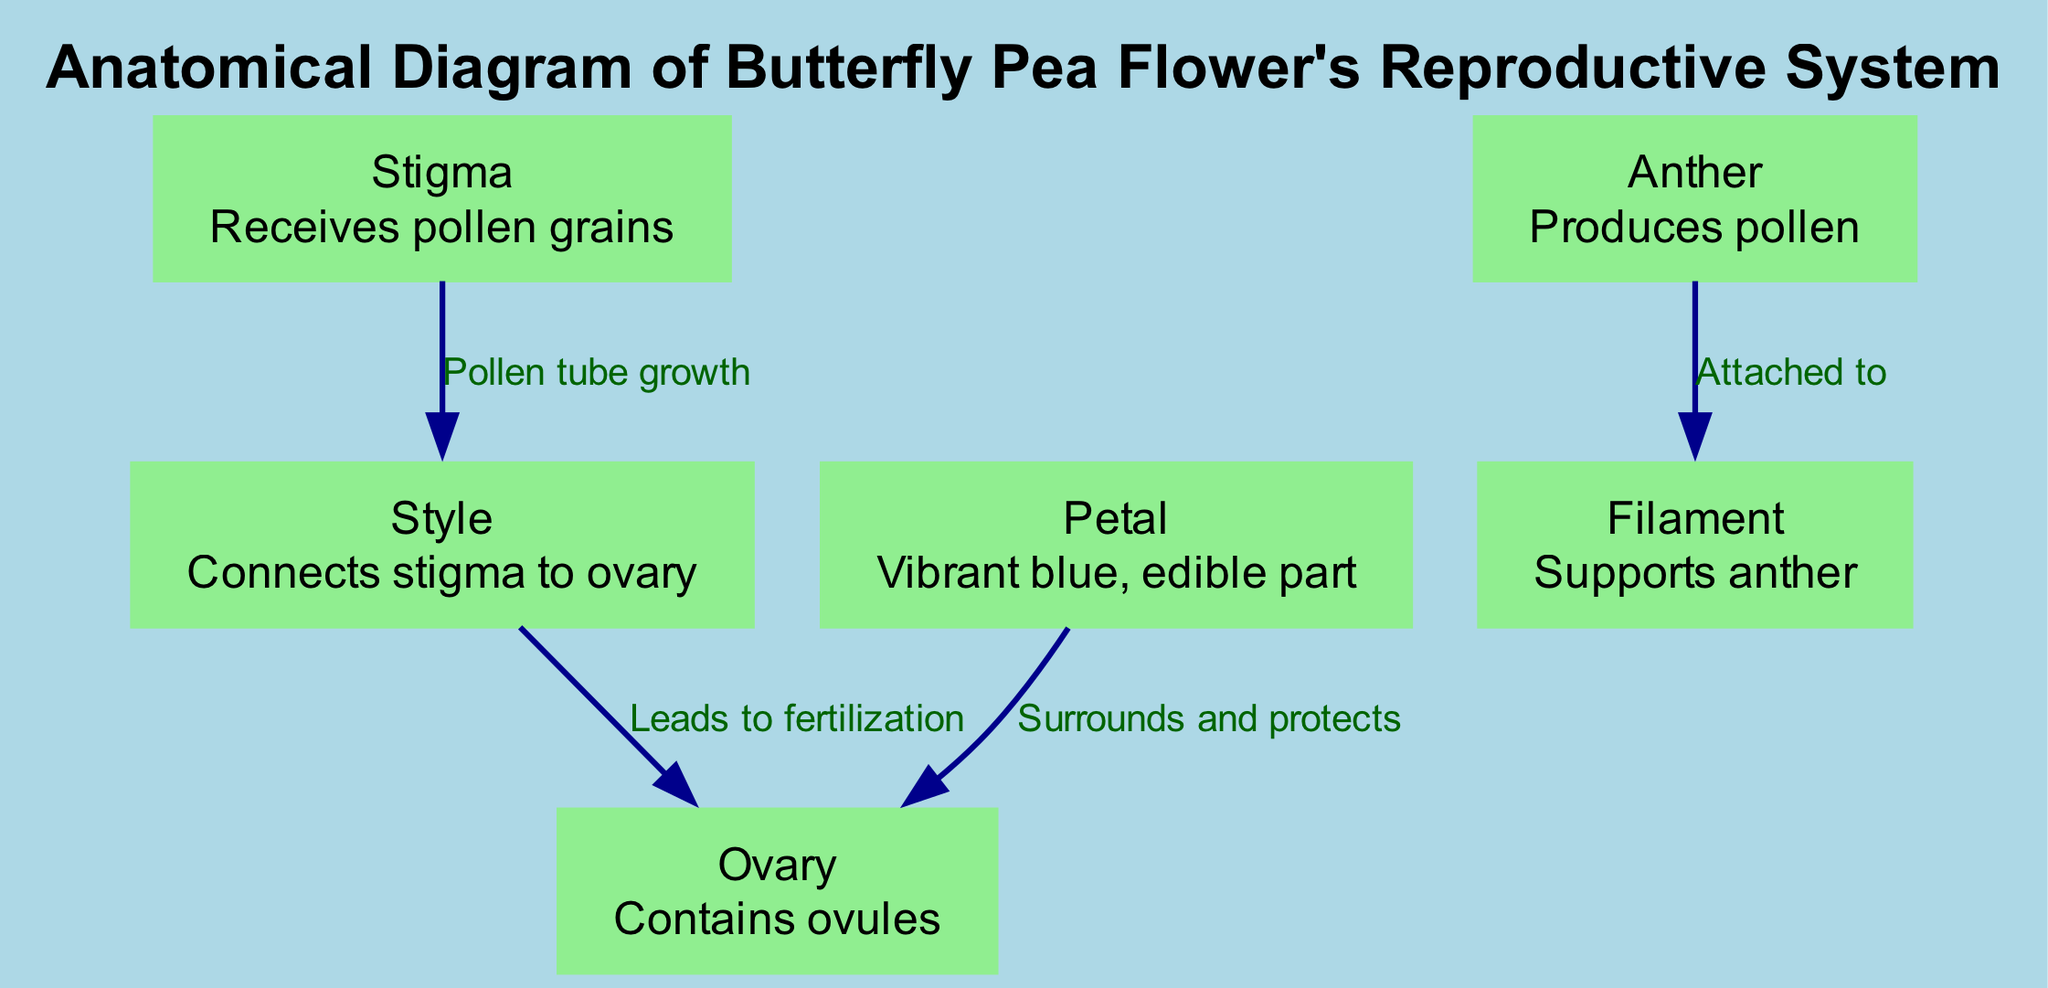What is the function of the stigma? The stigma is the part of the flower that receives pollen grains. This can be identified from the labeled description in the diagram that directly defines its role.
Answer: Receives pollen grains How many nodes are in the diagram? The diagram consists of six nodes, which can be counted by listing each labeled part of the flower: stigma, style, ovary, anther, filament, and petal.
Answer: 6 What connects the stigma to the ovary? The style connects the stigma to the ovary as indicated in the diagram, where the edges represent relationships, and one clearly shows the connection between these two nodes.
Answer: Style What surrounds and protects the ovary? The petal surrounds and protects the ovary, which is specified in the relationship indicated in the diagram, linking the petal directly to the ovary.
Answer: Petal What produces pollen? The anther is responsible for producing pollen, which is explicitly stated in the description associated with the anther node in the diagram.
Answer: Anther Which part leads to fertilization? The style is the part that leads to fertilization, based on the edge connecting the style to the ovary where fertilization occurs as noted in the diagram's relationships.
Answer: Style What are ovules contained in? The ovules are contained in the ovary, as per the description provided in the diagram that details the functionality of the ovary node.
Answer: Ovary Which part is a vibrant blue, edible part? The petal is described as the vibrant blue, edible part in the diagram. This information is directly found in the node details for the petal.
Answer: Petal How many edges are shown in the diagram? The diagram has five edges as they can be counted by reviewing all the connections made between the nodes, which determine the relationships illustrated.
Answer: 5 